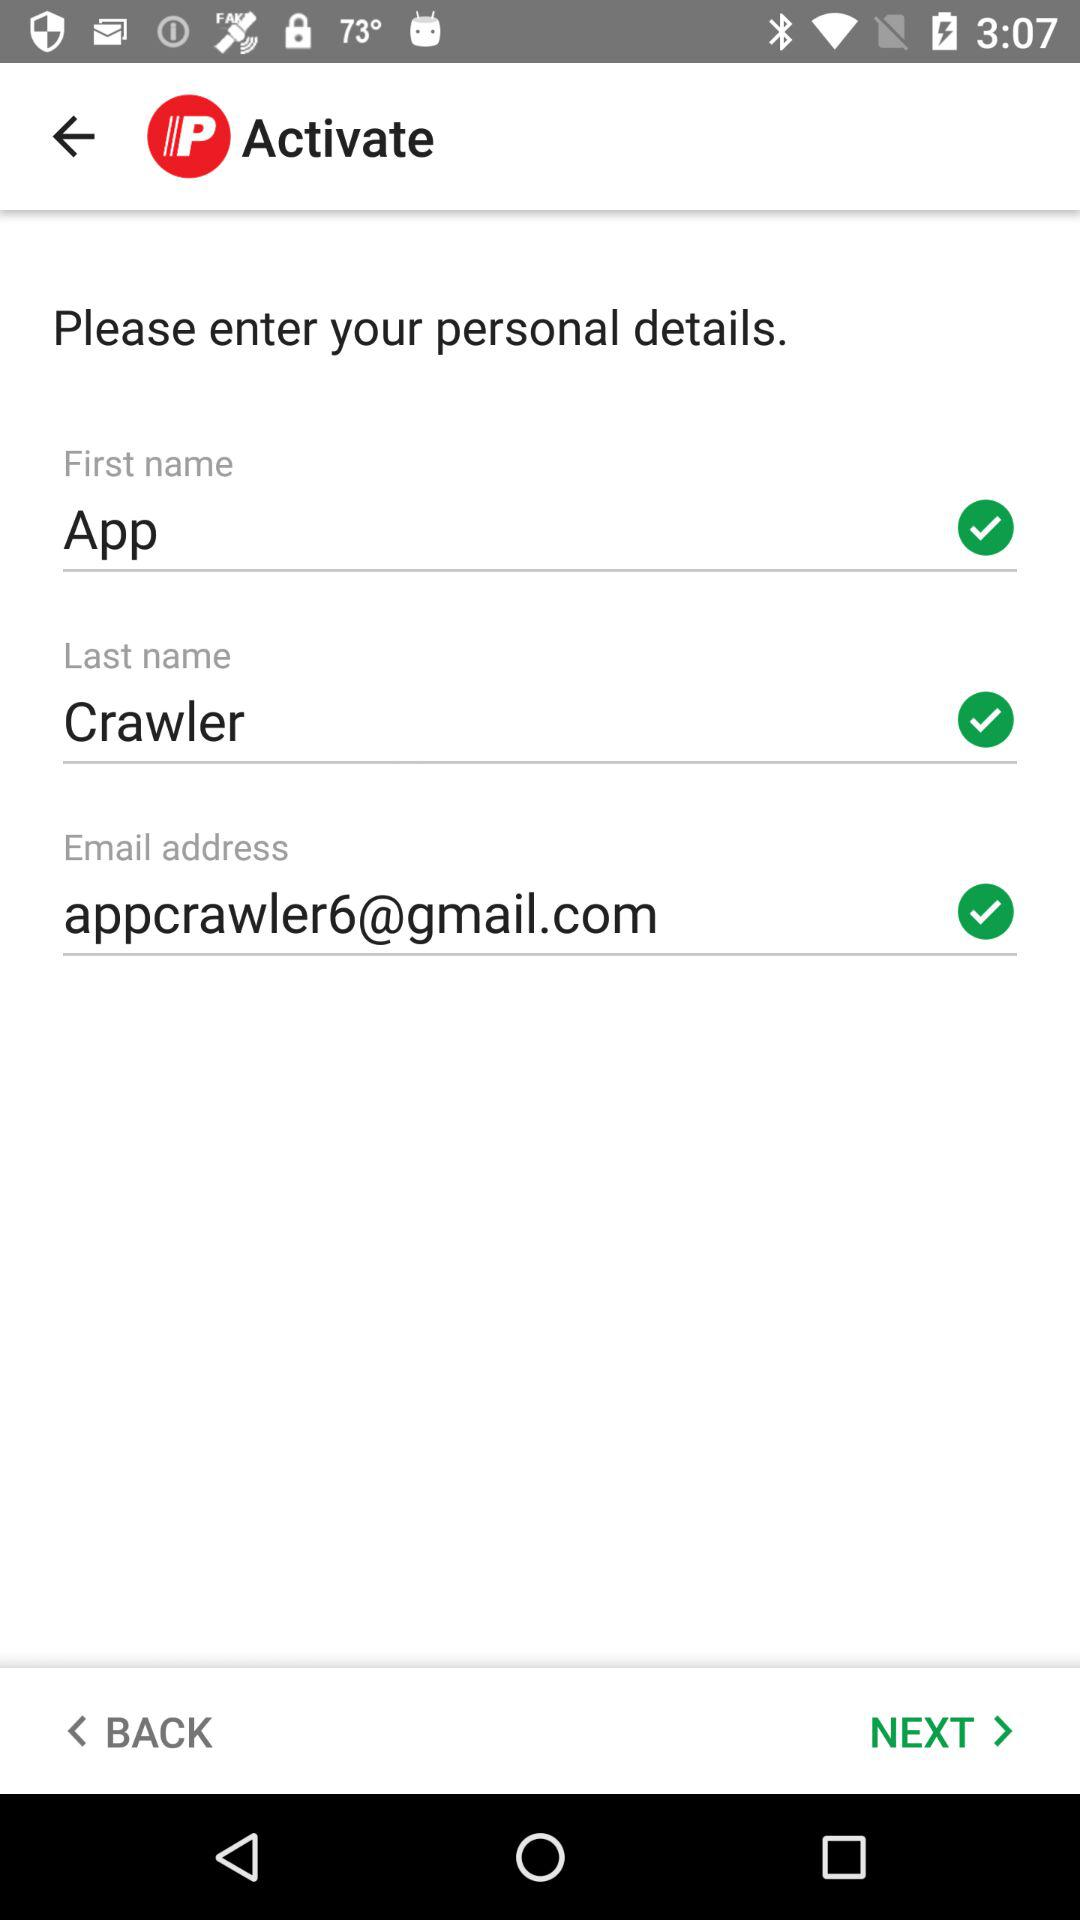How old is App Crawler?
When the provided information is insufficient, respond with <no answer>. <no answer> 